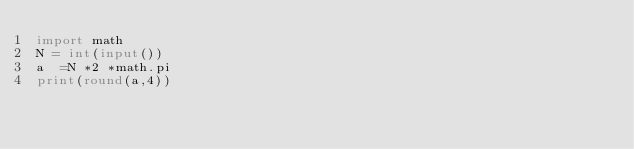Convert code to text. <code><loc_0><loc_0><loc_500><loc_500><_Python_>import math
N = int(input())
a  =N *2 *math.pi
print(round(a,4))</code> 